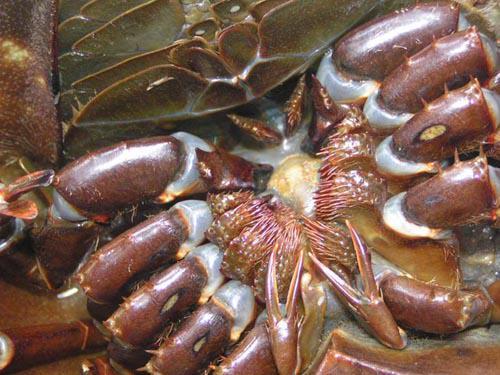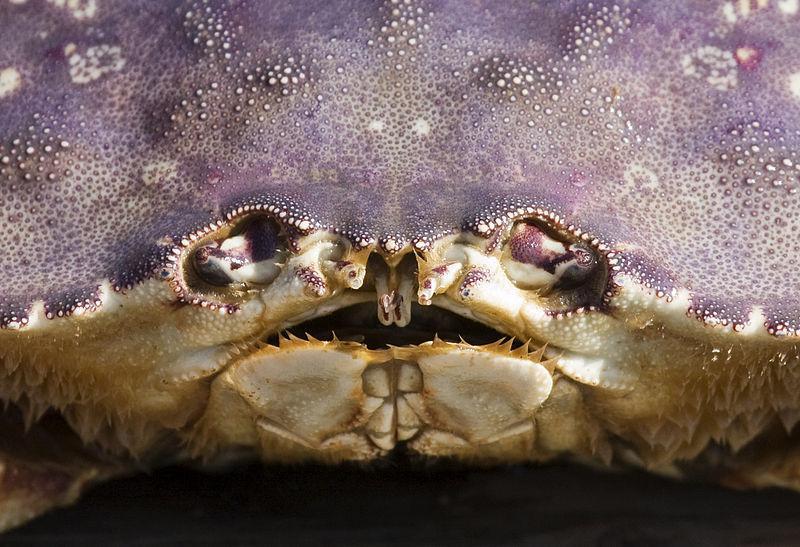The first image is the image on the left, the second image is the image on the right. Examine the images to the left and right. Is the description "In at least one image you can see a single crab top shell, two eye and a slightly opened mouth." accurate? Answer yes or no. Yes. The first image is the image on the left, the second image is the image on the right. Given the left and right images, does the statement "The right image shows the face of a shelled creature, and the left image shows an underside with some kind of appendages radiating from a center." hold true? Answer yes or no. Yes. 